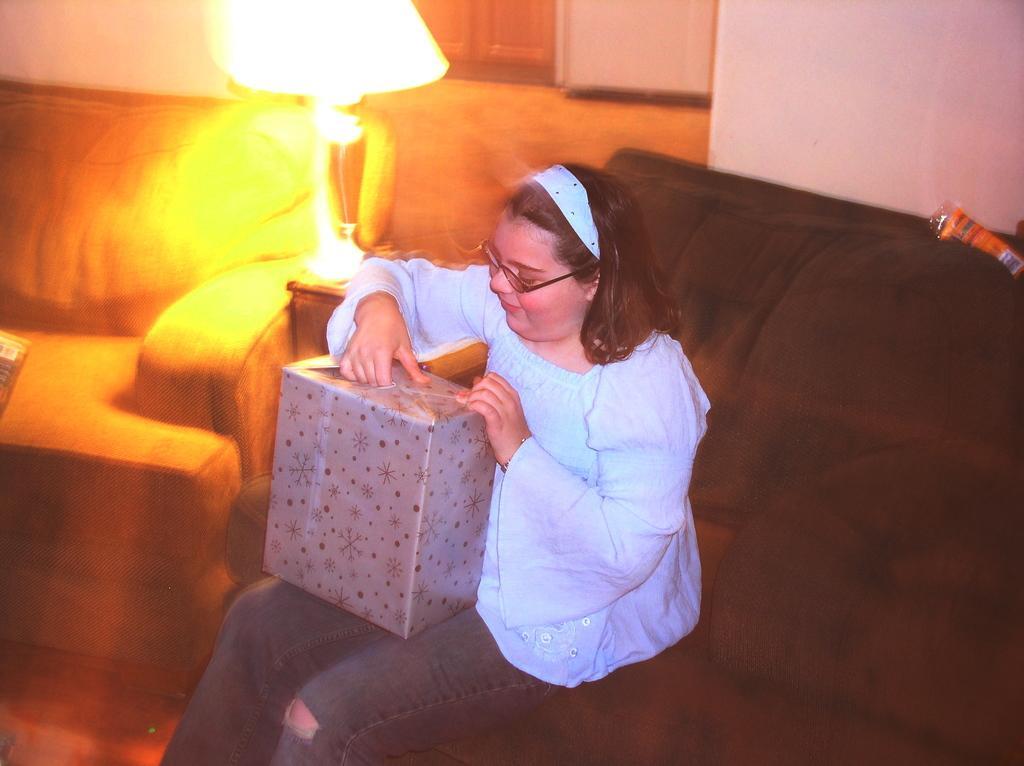Describe this image in one or two sentences. In this picture I can see a woman who is sitting in front and I see that she is sitting on a couch and I see a lamp left side to her and I see that she is holding a box which is covered with a wrapper. In the background I see the wall. 